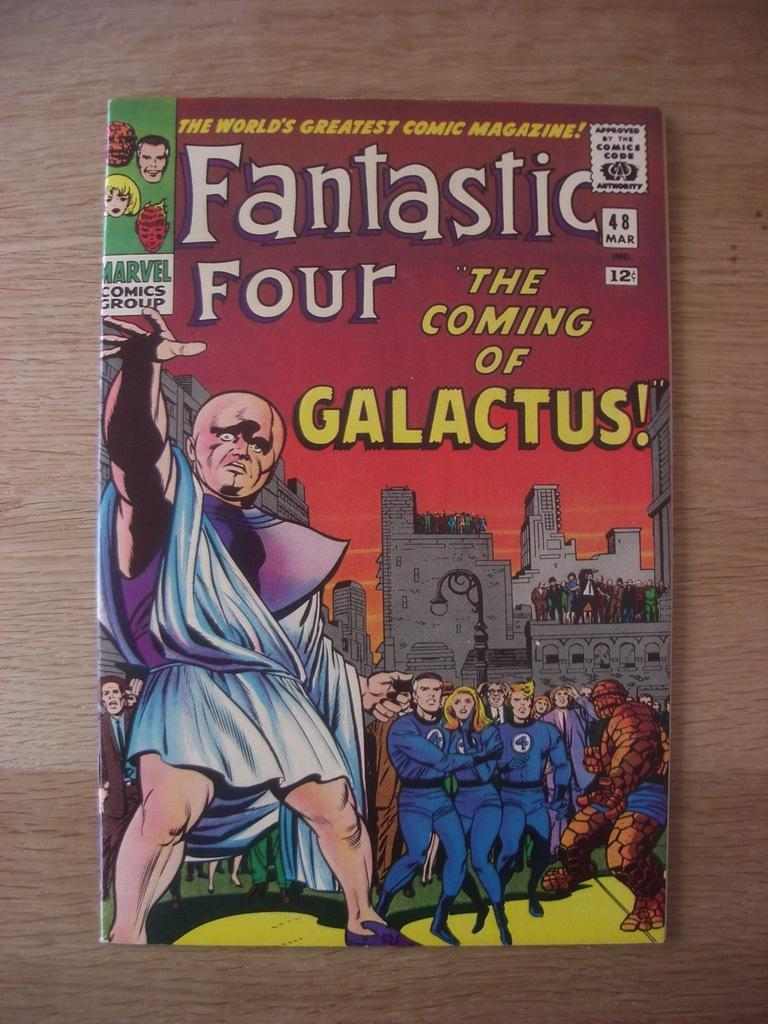<image>
Describe the image concisely. A Fantastic Four coming called The Coming of Galactus. 